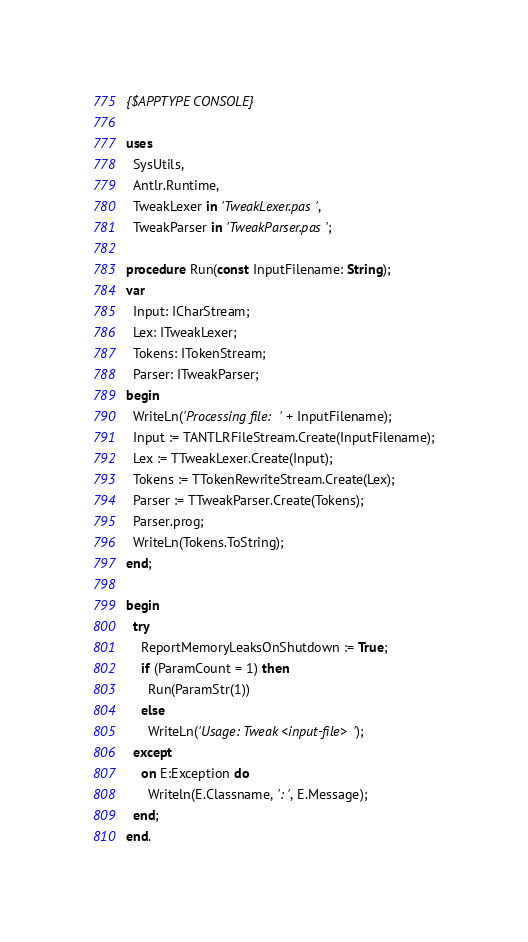Convert code to text. <code><loc_0><loc_0><loc_500><loc_500><_Pascal_>{$APPTYPE CONSOLE}

uses
  SysUtils,
  Antlr.Runtime,
  TweakLexer in 'TweakLexer.pas',
  TweakParser in 'TweakParser.pas';

procedure Run(const InputFilename: String);
var
  Input: ICharStream;
  Lex: ITweakLexer;
  Tokens: ITokenStream;
  Parser: ITweakParser;
begin
  WriteLn('Processing file: ' + InputFilename);
  Input := TANTLRFileStream.Create(InputFilename);
  Lex := TTweakLexer.Create(Input);
  Tokens := TTokenRewriteStream.Create(Lex);
  Parser := TTweakParser.Create(Tokens);
  Parser.prog;
  WriteLn(Tokens.ToString);
end;

begin
  try
    ReportMemoryLeaksOnShutdown := True;
    if (ParamCount = 1) then
      Run(ParamStr(1))
    else
      WriteLn('Usage: Tweak <input-file>');
  except
    on E:Exception do
      Writeln(E.Classname, ': ', E.Message);
  end;
end.
</code> 